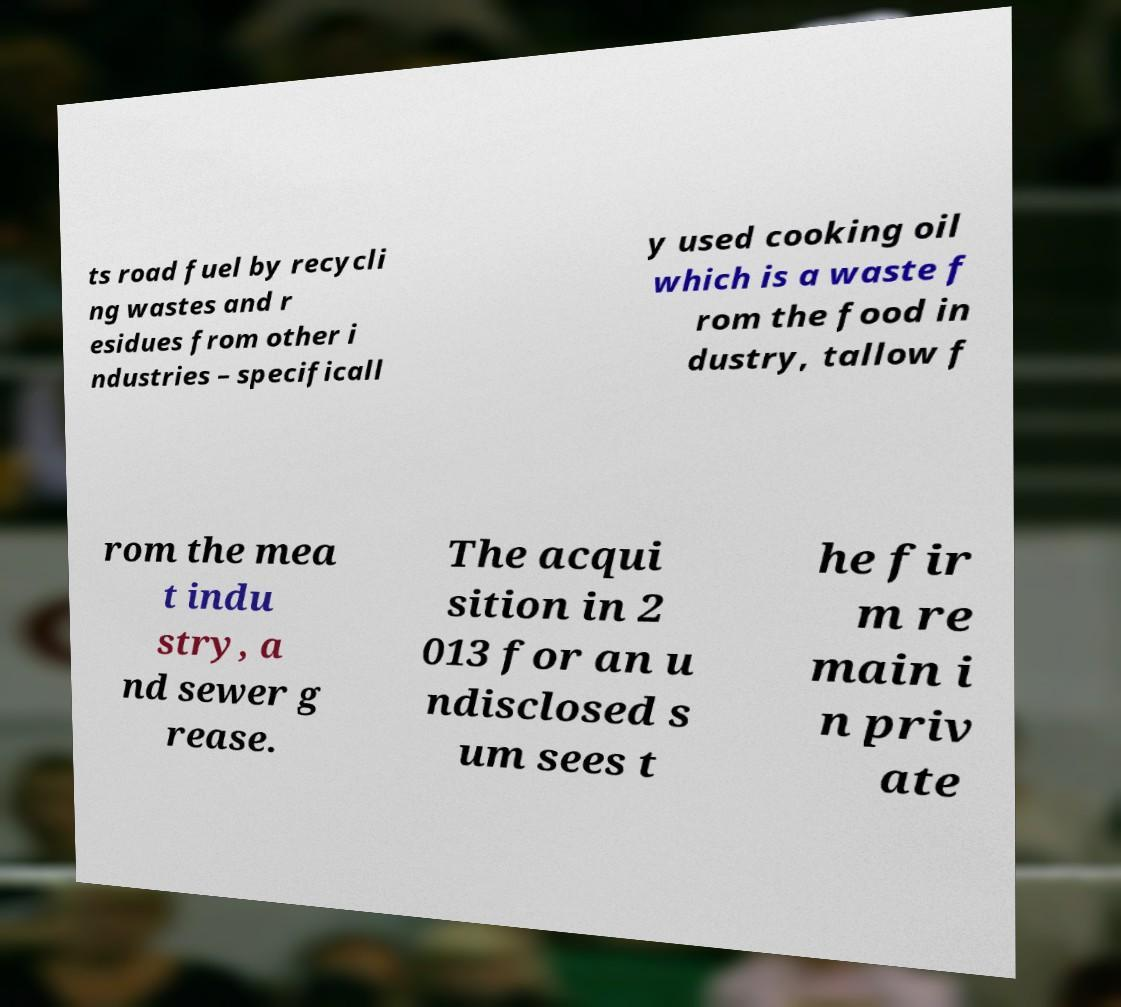Please read and relay the text visible in this image. What does it say? ts road fuel by recycli ng wastes and r esidues from other i ndustries – specificall y used cooking oil which is a waste f rom the food in dustry, tallow f rom the mea t indu stry, a nd sewer g rease. The acqui sition in 2 013 for an u ndisclosed s um sees t he fir m re main i n priv ate 